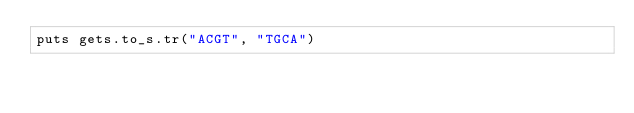Convert code to text. <code><loc_0><loc_0><loc_500><loc_500><_Crystal_>puts gets.to_s.tr("ACGT", "TGCA")</code> 